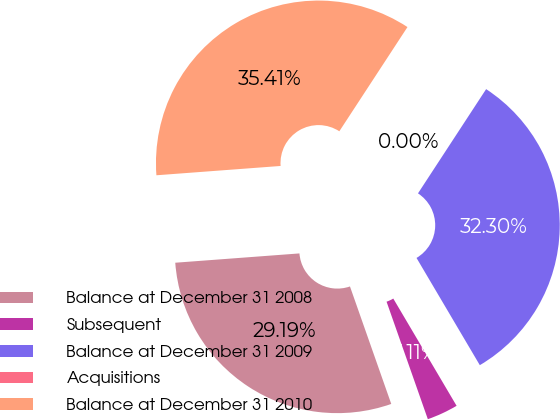Convert chart. <chart><loc_0><loc_0><loc_500><loc_500><pie_chart><fcel>Balance at December 31 2008<fcel>Subsequent<fcel>Balance at December 31 2009<fcel>Acquisitions<fcel>Balance at December 31 2010<nl><fcel>29.19%<fcel>3.11%<fcel>32.3%<fcel>0.0%<fcel>35.41%<nl></chart> 